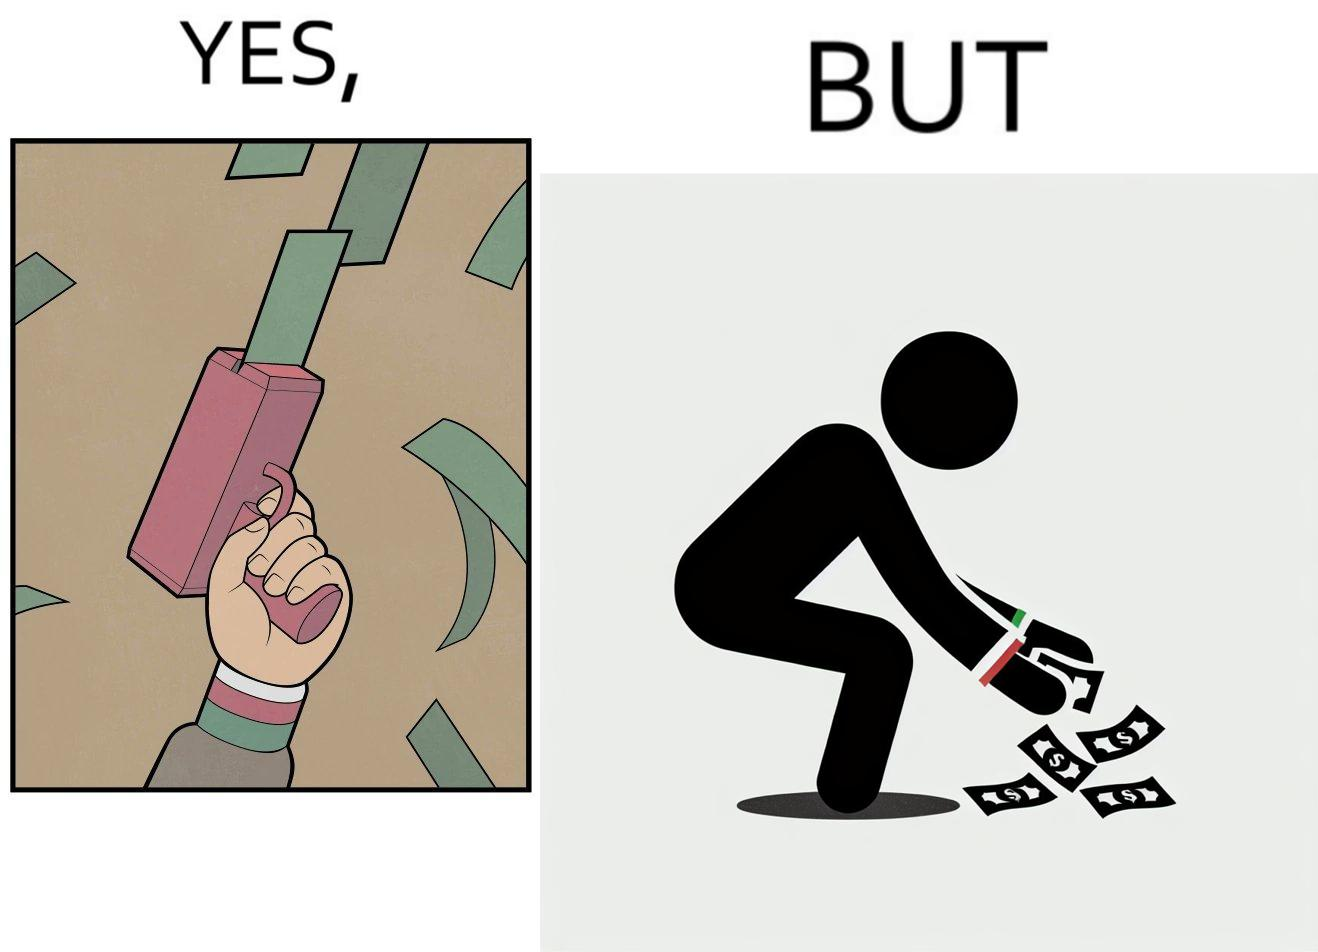Provide a description of this image. The image is satirical because the man that is shooting money in the air causing a rain of money bills is the same person who is crouching down to collect the fallen dollar bills from the ground which makes the act of shooting bills in the air not so fun. 